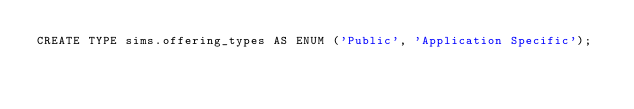Convert code to text. <code><loc_0><loc_0><loc_500><loc_500><_SQL_>CREATE TYPE sims.offering_types AS ENUM ('Public', 'Application Specific');</code> 